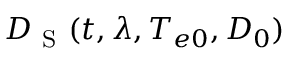Convert formula to latex. <formula><loc_0><loc_0><loc_500><loc_500>D _ { S } ( t , \lambda , T _ { e 0 } , D _ { 0 } )</formula> 